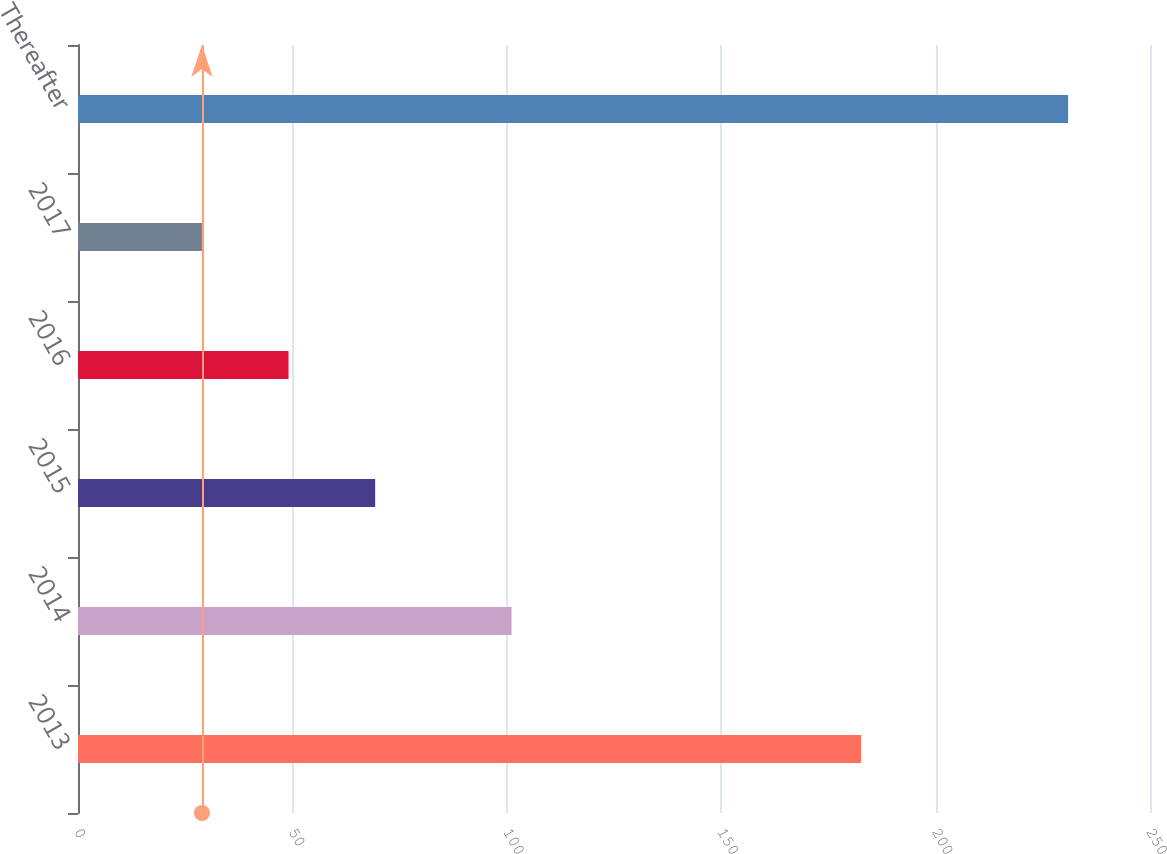Convert chart. <chart><loc_0><loc_0><loc_500><loc_500><bar_chart><fcel>2013<fcel>2014<fcel>2015<fcel>2016<fcel>2017<fcel>Thereafter<nl><fcel>182.6<fcel>101.1<fcel>69.3<fcel>49.1<fcel>28.9<fcel>230.9<nl></chart> 